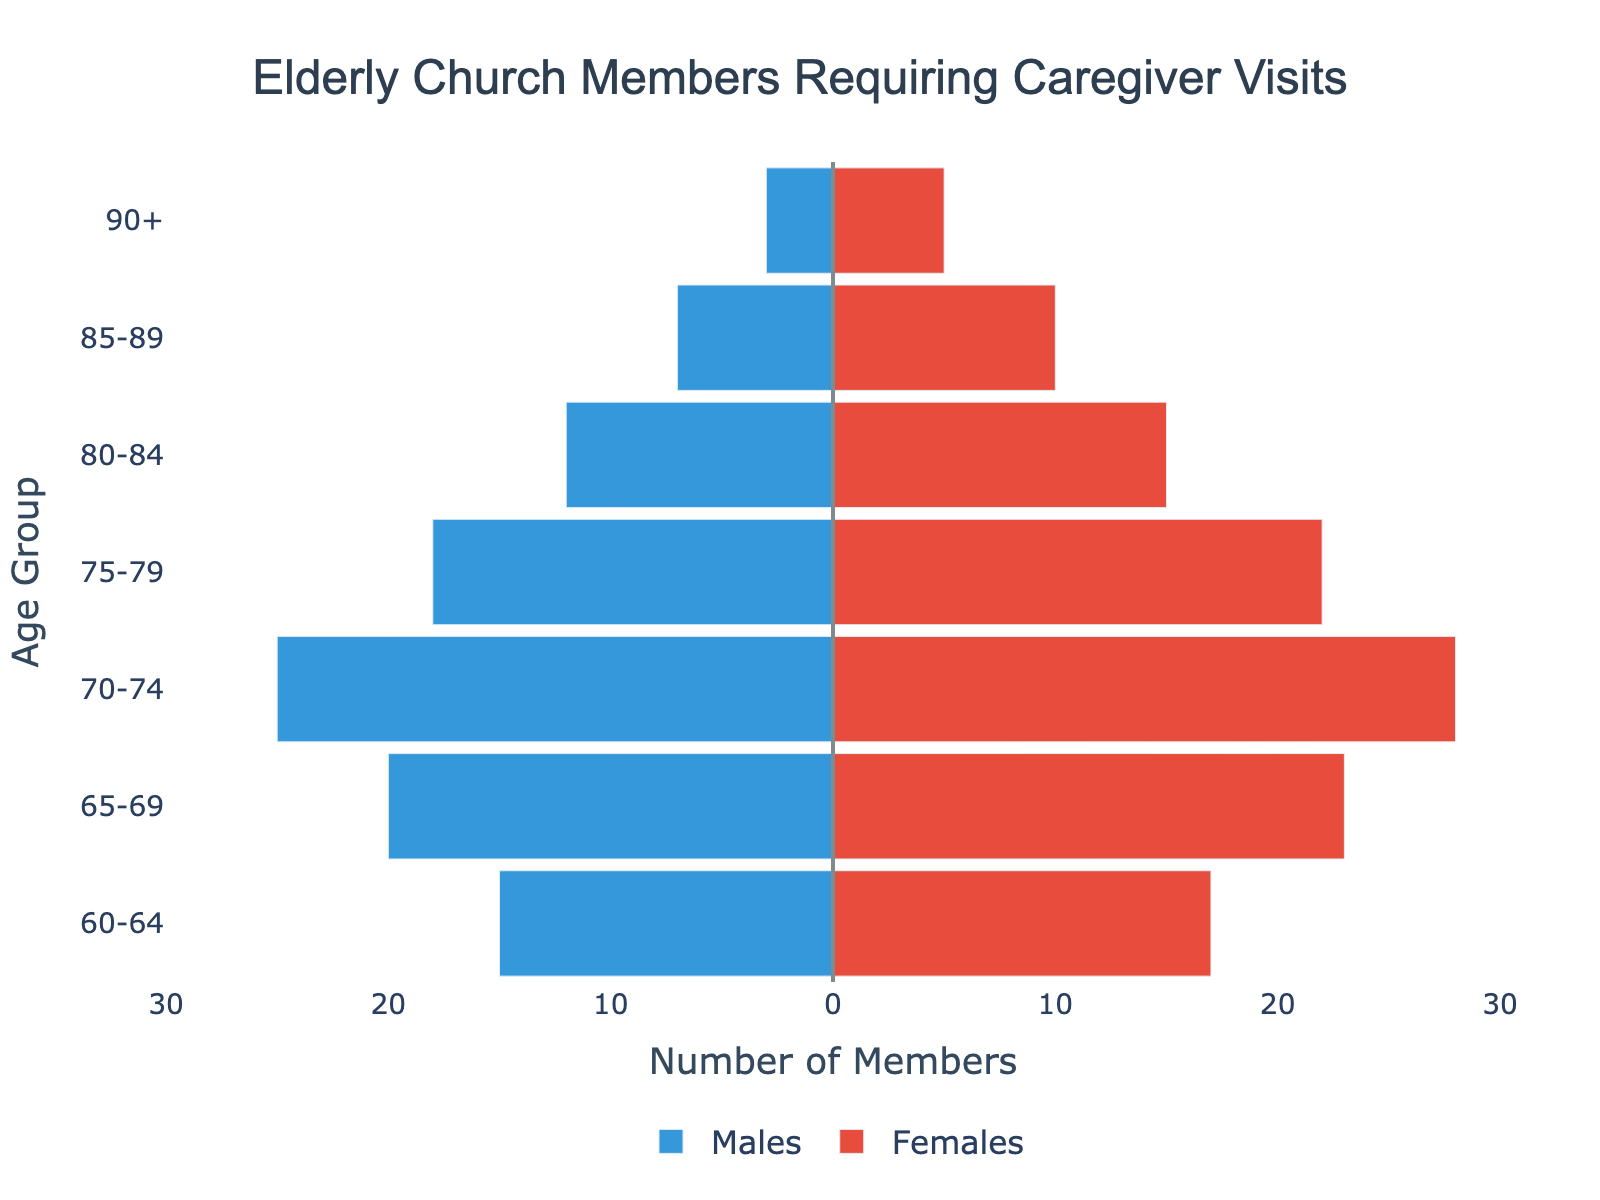What is the title of the figure? The title is usually located at the top of the figure, and it provides a brief description of what the figure represents. In this case, based on the provided data and code, the title is clearly stated.
Answer: Elderly Church Members Requiring Caregiver Visits How many male and female members are there in the 75-79 age group? To find the number of male and female members in the 75-79 age group, look at the bars representing this age group. The exact numbers will be visible on the x-axis and the bars themselves.
Answer: 18 males and 22 females Which age group has the highest number of female members? Compare the lengths of the female bars for each age group. The bar that extends the farthest to the right corresponds to the age group with the highest number of female members.
Answer: 75-79 How does the number of male members in the 60-64 age group compare to the number of female members in the same group? Check the lengths of the bars for both males and females in the 60-64 age group. Subtract the number of males from the number of females to find the difference.
Answer: 2 fewer males What is the total number of elderly church members (both males and females) in the 90+ age group? Sum the number of males and females in the 90+ age group by adding the values shown for both genders in that age group.
Answer: 8 Which age group has the most significant difference between the number of male and female members? Calculate the difference between the number of male and female members for each age group and compare these differences to find the largest one.
Answer: 75-79 How many age groups have more female members than male members? For each age group, compare the numbers of male and female members. Count the age groups where the number of female members exceeds that of male members.
Answer: 7 What is the overall range of values shown on the x-axis? The x-axis range is provided in the figure layout settings. Look at the minimum and maximum values indicated on the x-axis to determine the range.
Answer: -30 to 30 